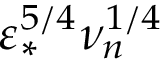Convert formula to latex. <formula><loc_0><loc_0><loc_500><loc_500>\varepsilon _ { * } ^ { 5 / 4 } \nu _ { n } ^ { 1 / 4 }</formula> 